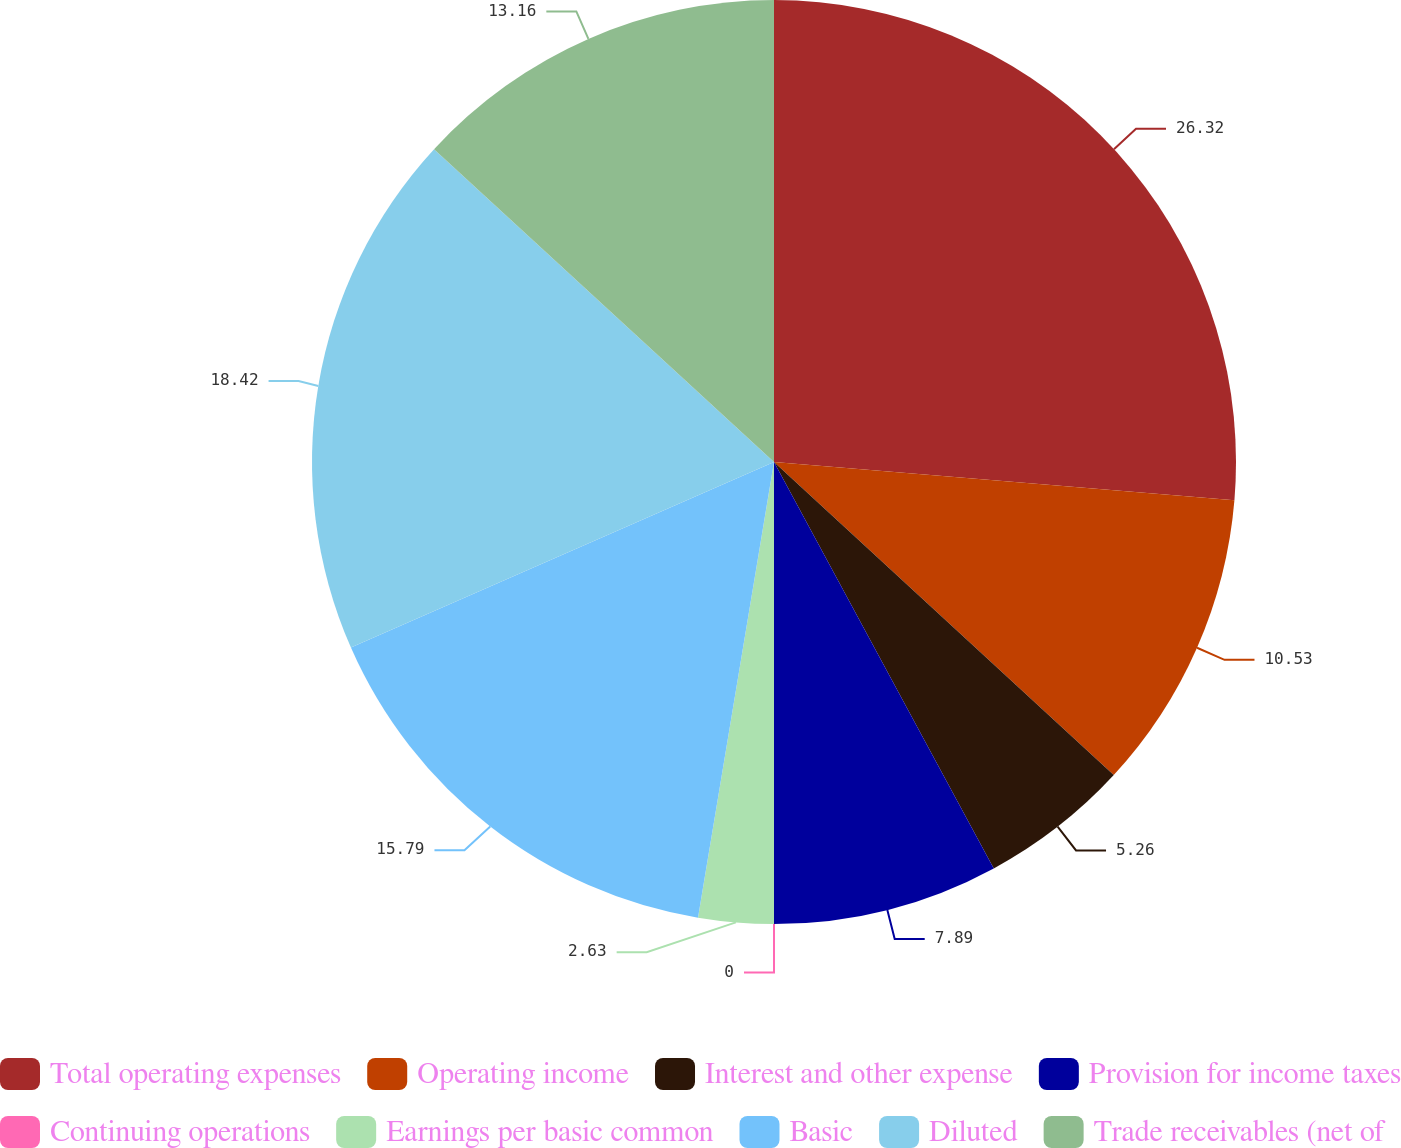Convert chart to OTSL. <chart><loc_0><loc_0><loc_500><loc_500><pie_chart><fcel>Total operating expenses<fcel>Operating income<fcel>Interest and other expense<fcel>Provision for income taxes<fcel>Continuing operations<fcel>Earnings per basic common<fcel>Basic<fcel>Diluted<fcel>Trade receivables (net of<nl><fcel>26.32%<fcel>10.53%<fcel>5.26%<fcel>7.89%<fcel>0.0%<fcel>2.63%<fcel>15.79%<fcel>18.42%<fcel>13.16%<nl></chart> 